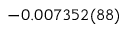Convert formula to latex. <formula><loc_0><loc_0><loc_500><loc_500>- 0 . 0 0 7 3 5 2 ( 8 8 )</formula> 